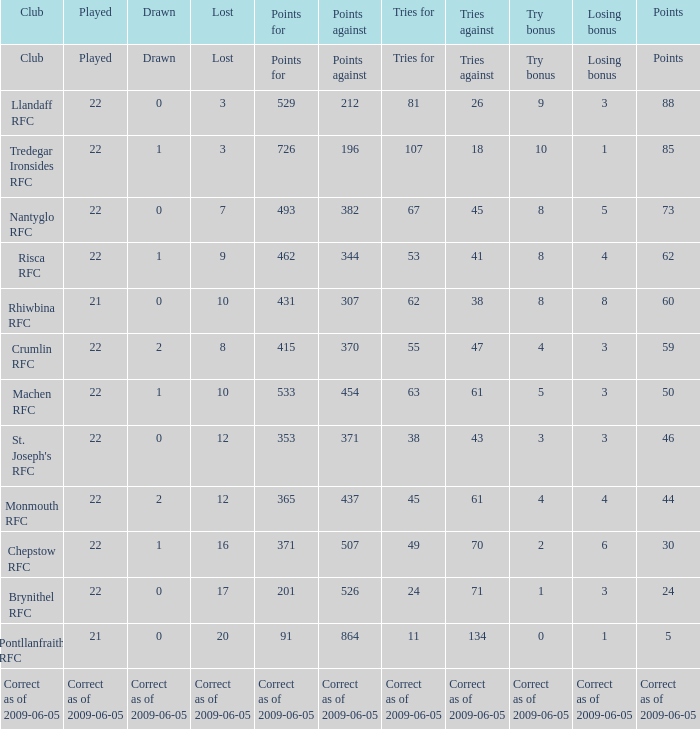If points against amounted to 371, what is the stalemate? 0.0. 